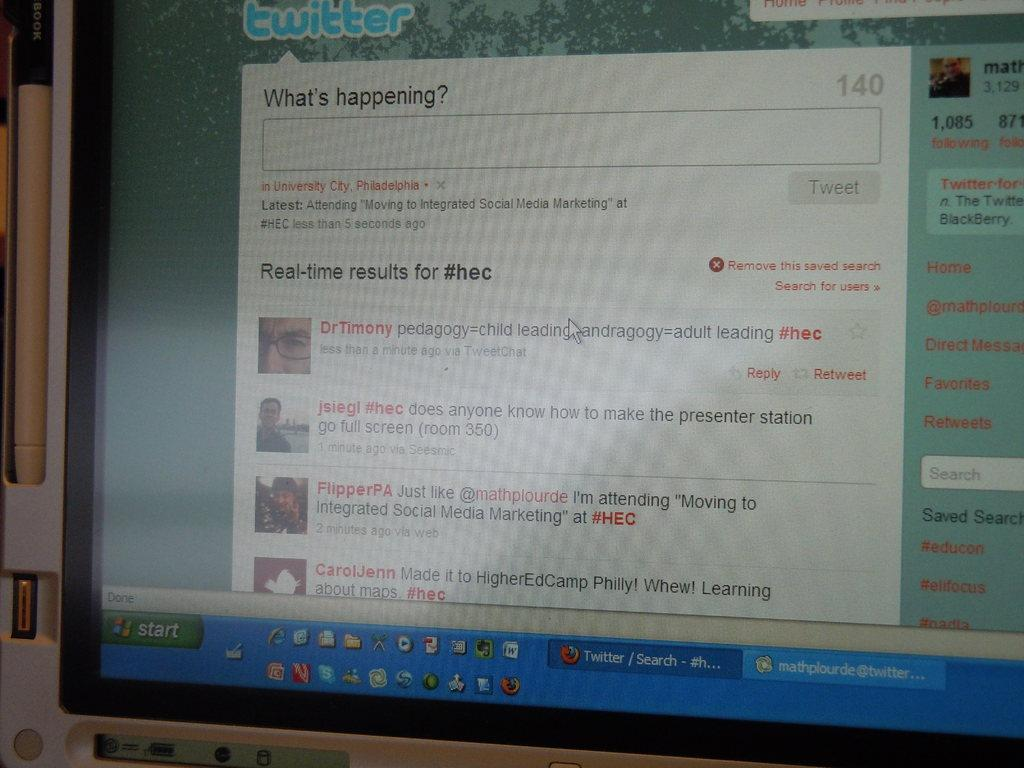<image>
Describe the image concisely. A computer with Twitter on its web browser. 